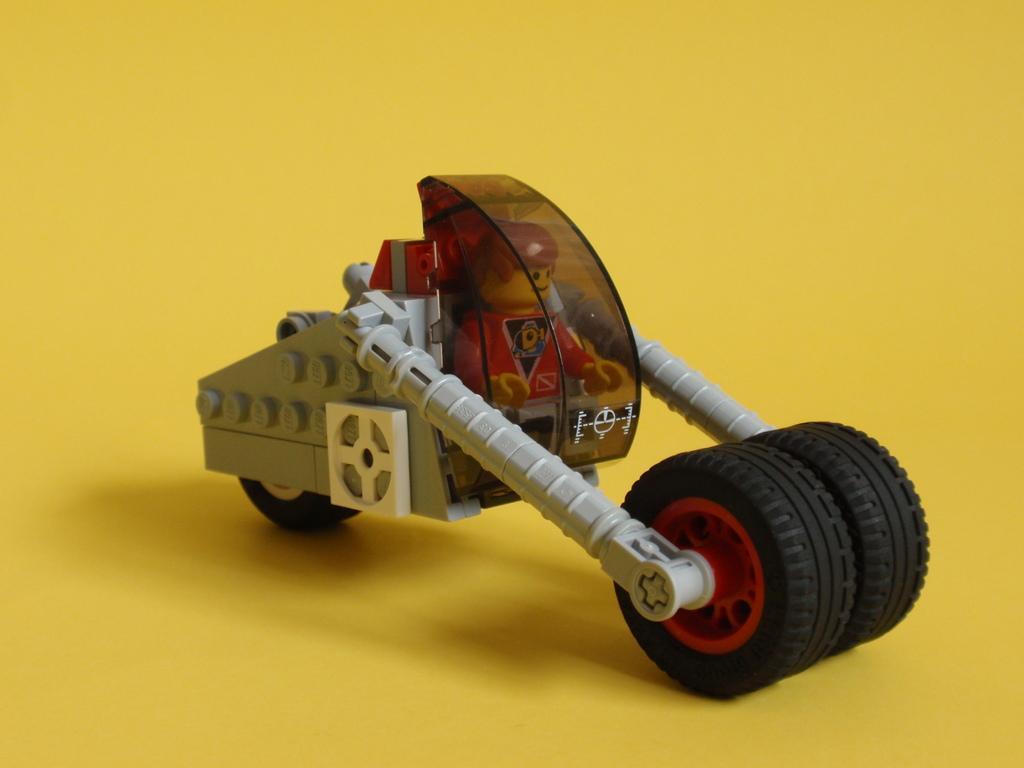Describe this image in one or two sentences. In this image we can see one toy and there is a yellow color background. 